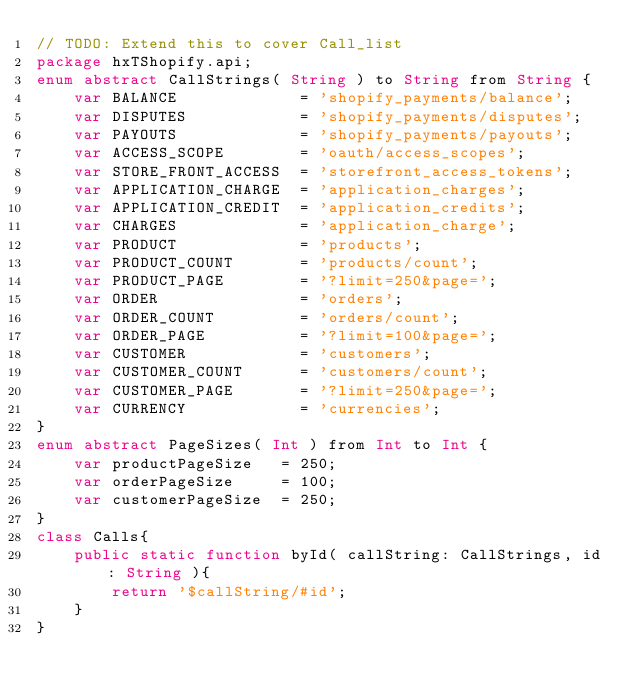Convert code to text. <code><loc_0><loc_0><loc_500><loc_500><_Haxe_>// TODO: Extend this to cover Call_list
package hxTShopify.api;
enum abstract CallStrings( String ) to String from String {
    var BALANCE             = 'shopify_payments/balance';
    var DISPUTES            = 'shopify_payments/disputes';
    var PAYOUTS             = 'shopify_payments/payouts';
    var ACCESS_SCOPE        = 'oauth/access_scopes';
    var STORE_FRONT_ACCESS  = 'storefront_access_tokens';
    var APPLICATION_CHARGE  = 'application_charges';
    var APPLICATION_CREDIT  = 'application_credits';
    var CHARGES             = 'application_charge';
    var PRODUCT             = 'products';
    var PRODUCT_COUNT       = 'products/count';
    var PRODUCT_PAGE        = '?limit=250&page=';
    var ORDER               = 'orders';
    var ORDER_COUNT         = 'orders/count';
    var ORDER_PAGE          = '?limit=100&page=';
    var CUSTOMER            = 'customers';
    var CUSTOMER_COUNT      = 'customers/count';
    var CUSTOMER_PAGE       = '?limit=250&page=';
    var CURRENCY            = 'currencies';
}
enum abstract PageSizes( Int ) from Int to Int {
    var productPageSize   = 250;
    var orderPageSize     = 100;
    var customerPageSize  = 250;
}
class Calls{
    public static function byId( callString: CallStrings, id: String ){
        return '$callString/#id';
    }
}
</code> 